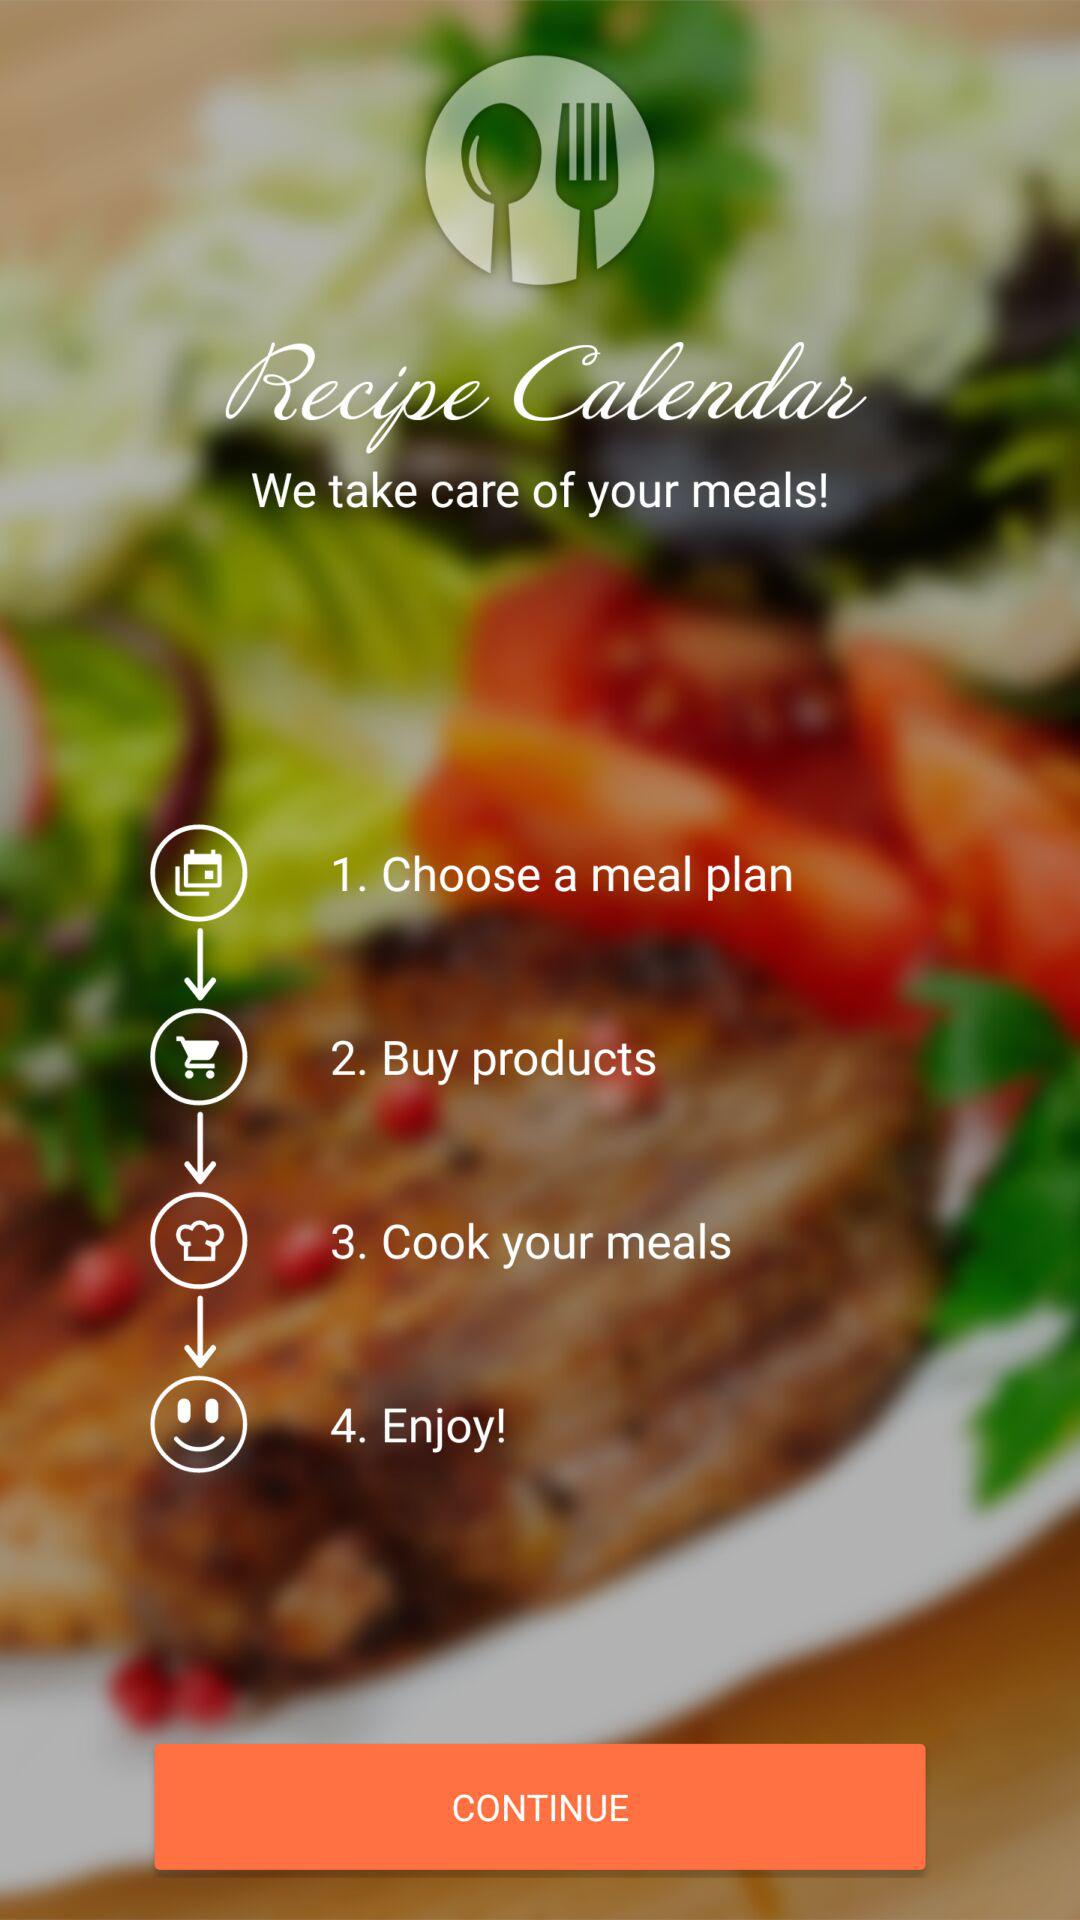How many steps are in the recipe calendar?
Answer the question using a single word or phrase. 4 